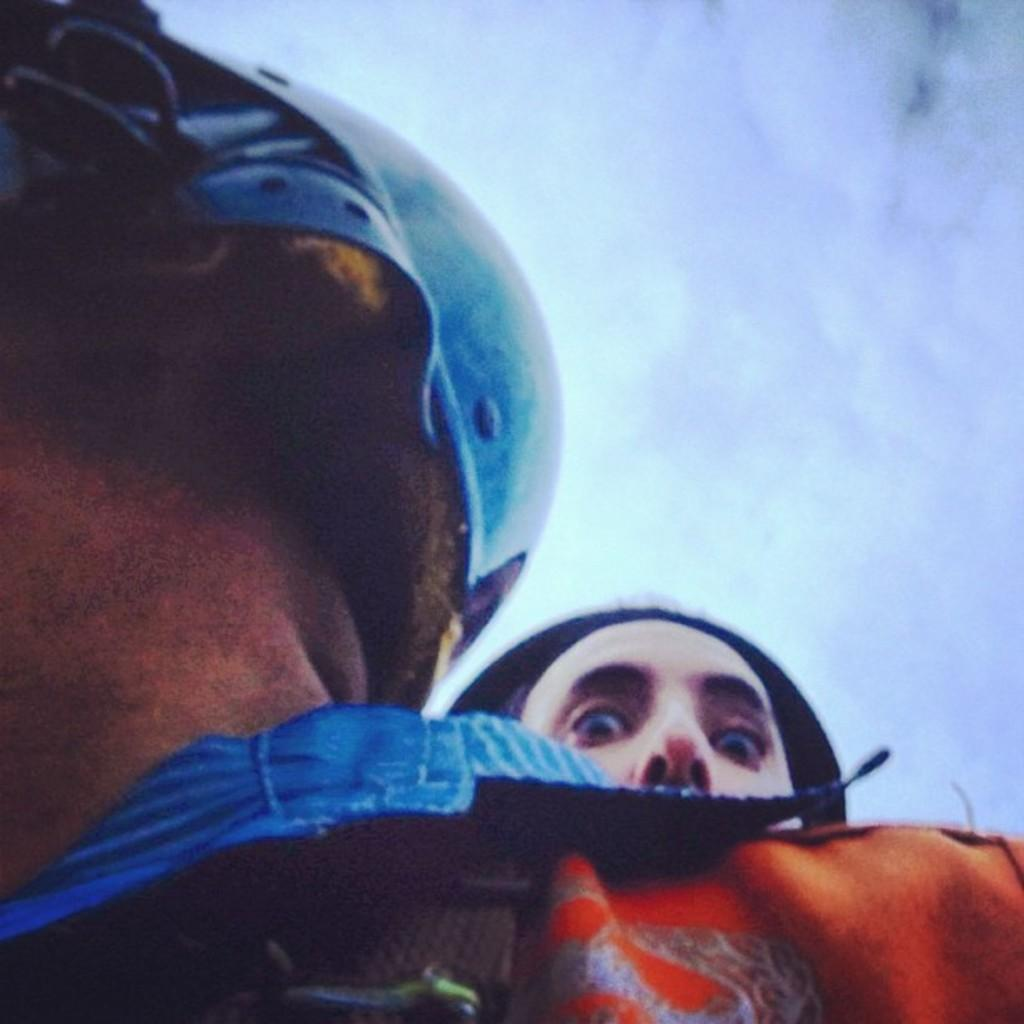How many people are in the image? There are two persons in the image. What is one of the persons wearing? One of the persons is wearing a helmet. What can be seen on the right side of the image? There are clouds visible on the right side of the image. What is visible in the entirety in the image? The sky is visible in the image. What is the name of the invention that the person is using in the image? There is no invention visible in the image, and the person is not using any specific device or tool. 